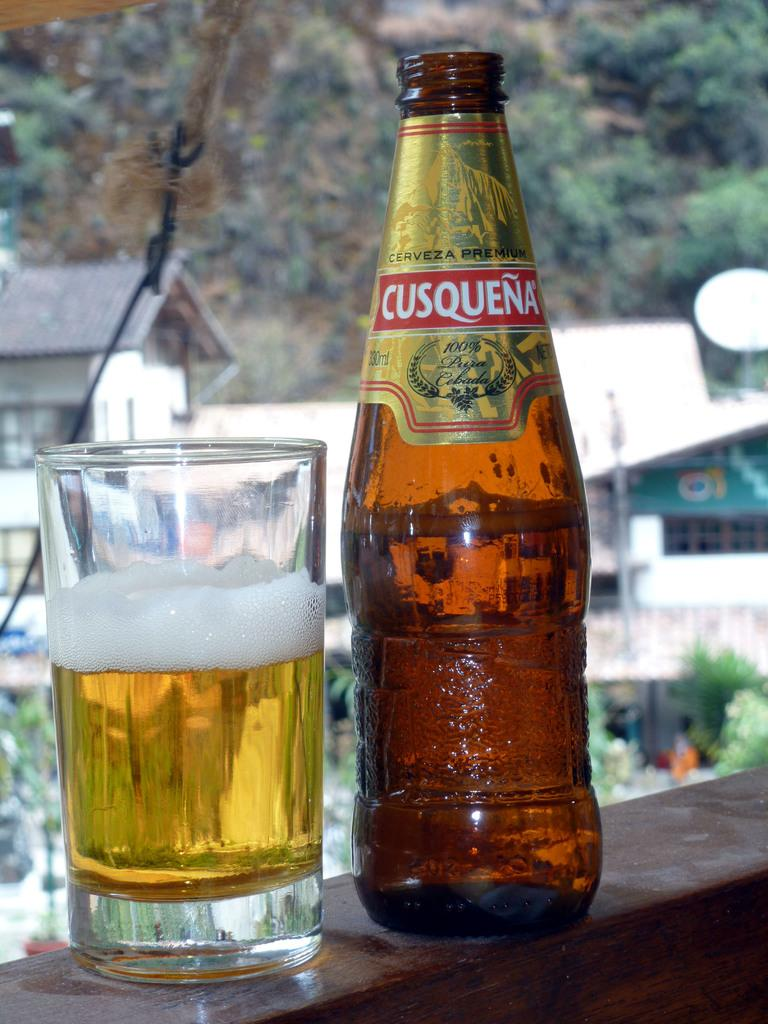<image>
Offer a succinct explanation of the picture presented. A glass into which some of a bottle of Cusqueña has been poured. 